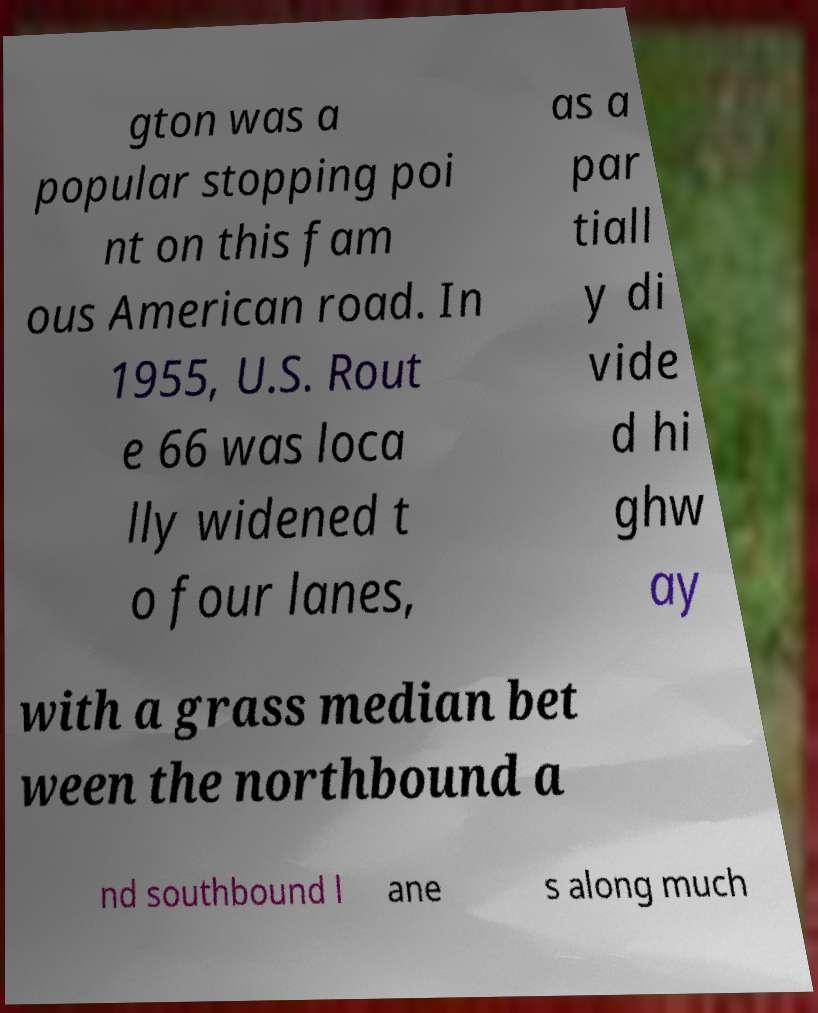Please identify and transcribe the text found in this image. gton was a popular stopping poi nt on this fam ous American road. In 1955, U.S. Rout e 66 was loca lly widened t o four lanes, as a par tiall y di vide d hi ghw ay with a grass median bet ween the northbound a nd southbound l ane s along much 